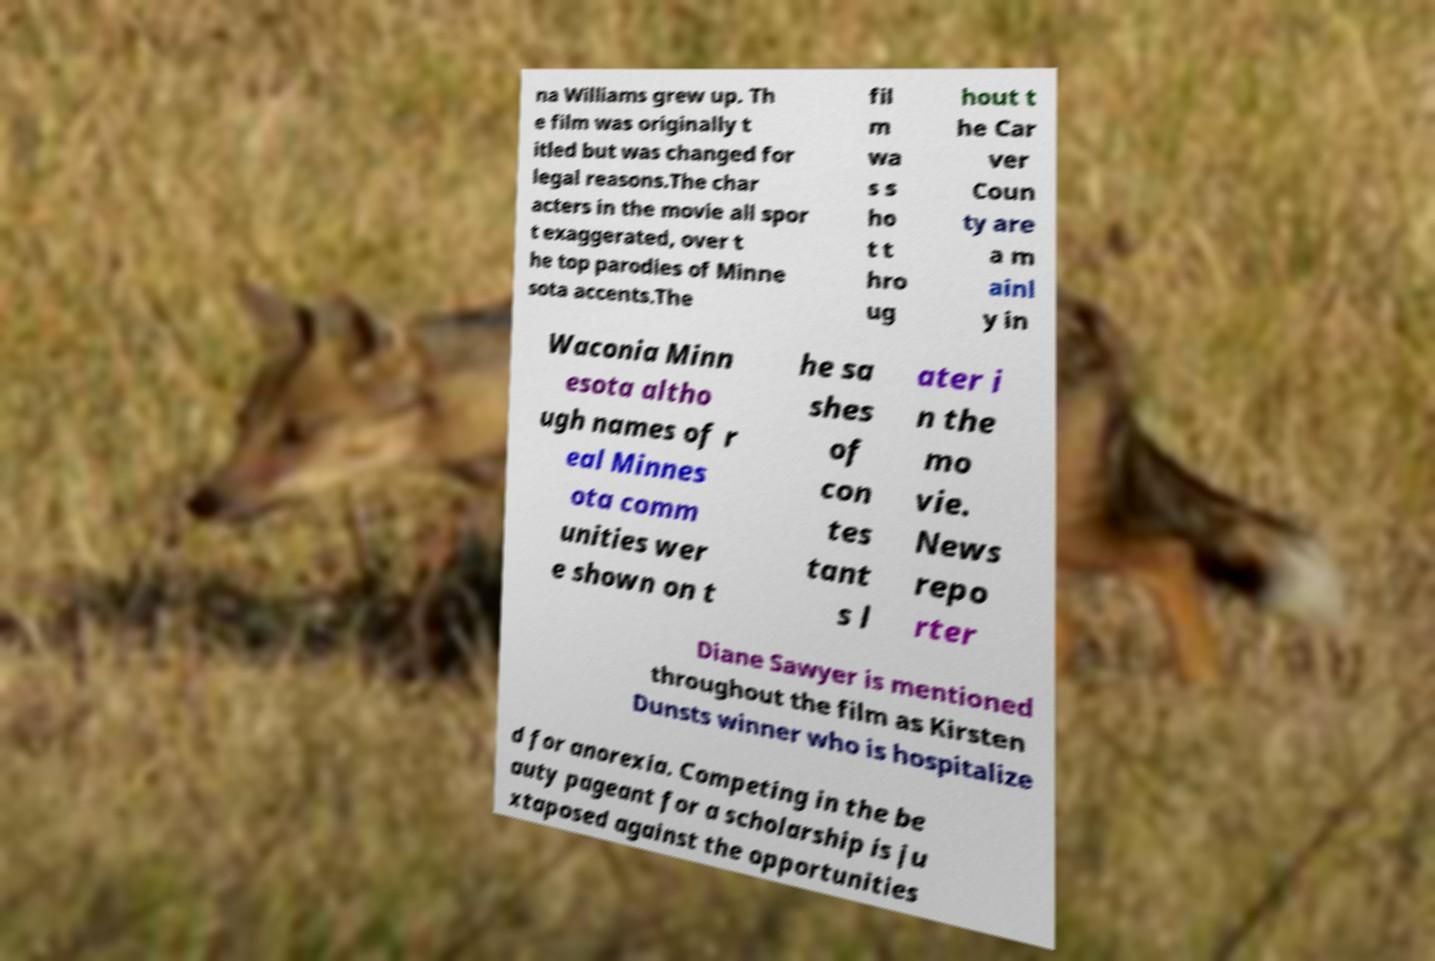Please identify and transcribe the text found in this image. na Williams grew up. Th e film was originally t itled but was changed for legal reasons.The char acters in the movie all spor t exaggerated, over t he top parodies of Minne sota accents.The fil m wa s s ho t t hro ug hout t he Car ver Coun ty are a m ainl y in Waconia Minn esota altho ugh names of r eal Minnes ota comm unities wer e shown on t he sa shes of con tes tant s l ater i n the mo vie. News repo rter Diane Sawyer is mentioned throughout the film as Kirsten Dunsts winner who is hospitalize d for anorexia. Competing in the be auty pageant for a scholarship is ju xtaposed against the opportunities 